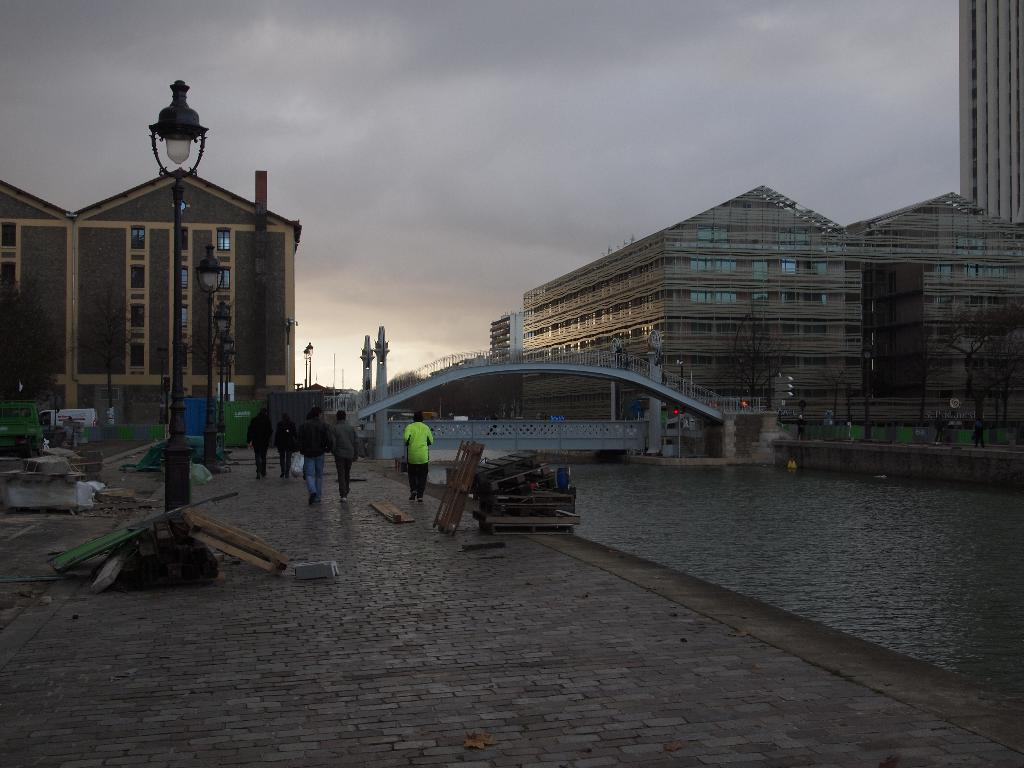What type of natural feature is present in the image? There is a lake in the image. What structure can be seen crossing the lake? There is a bridge in the image. What is the purpose of the light pole in the image? The light pole is likely for illuminating the area at night. What can be seen in the distance in the image? There are buildings visible in the background of the image. What is the condition of the sky in the image? The sky is full of clouds in the image. What are the people in the image doing? People are walking on the road on the left side of the image. How many robins are perched on the light pole in the image? There are no robins present in the image; the light pole is the only object visible on it. 